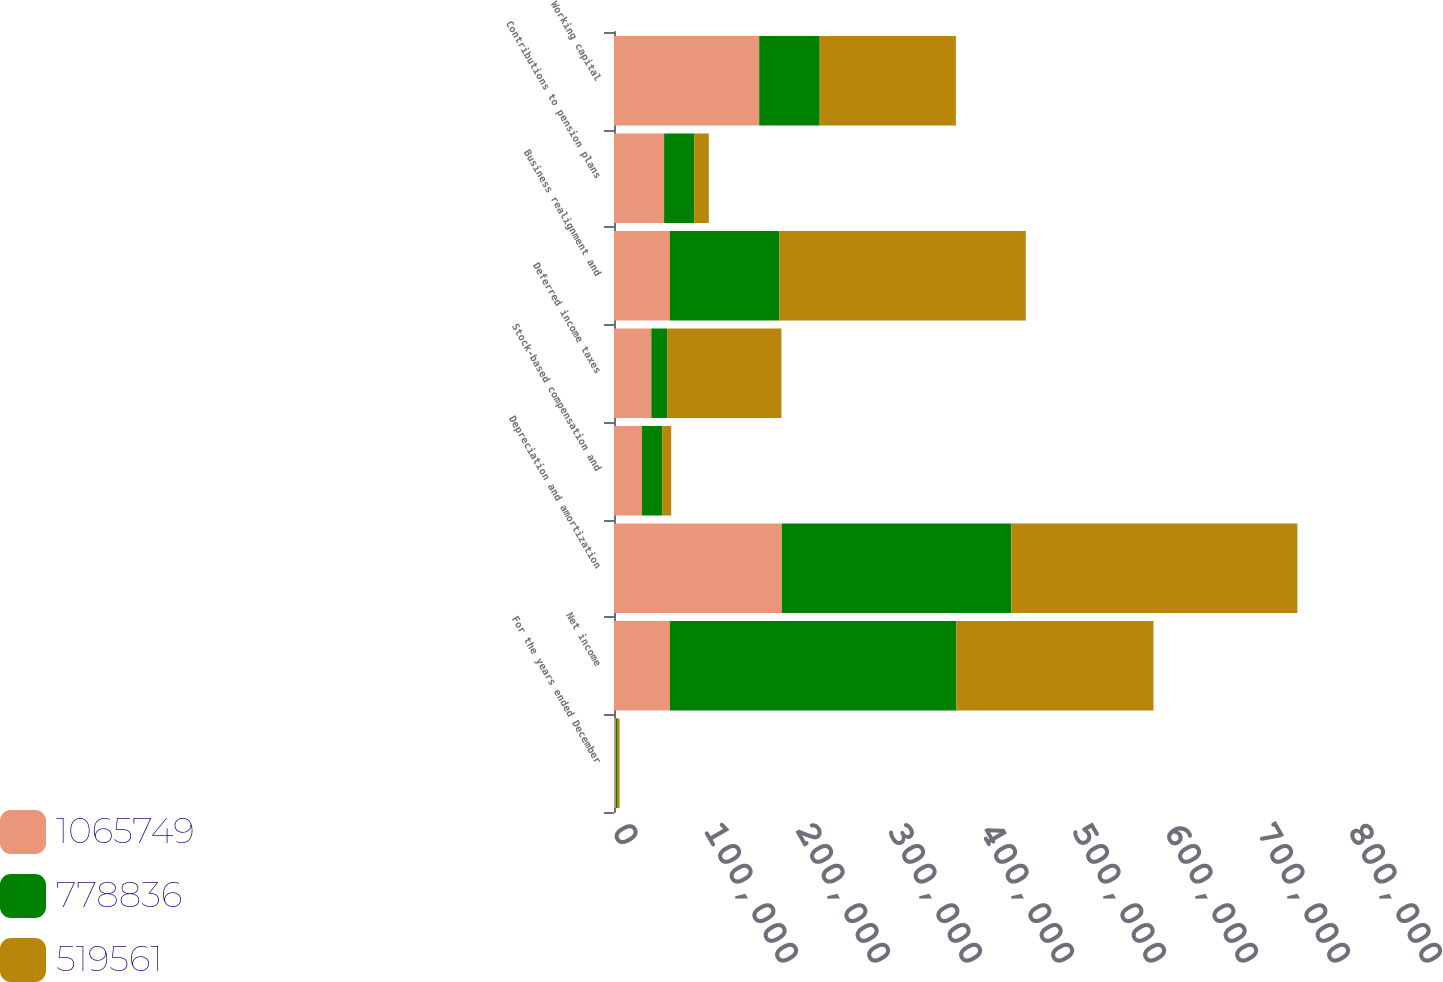Convert chart to OTSL. <chart><loc_0><loc_0><loc_500><loc_500><stacked_bar_chart><ecel><fcel>For the years ended December<fcel>Net income<fcel>Depreciation and amortization<fcel>Stock-based compensation and<fcel>Deferred income taxes<fcel>Business realignment and<fcel>Contributions to pension plans<fcel>Working capital<nl><fcel>1.06575e+06<fcel>2009<fcel>60823<fcel>182411<fcel>30472<fcel>40578<fcel>60823<fcel>54457<fcel>157812<nl><fcel>778836<fcel>2008<fcel>311405<fcel>249491<fcel>22196<fcel>17125<fcel>119117<fcel>32759<fcel>65791<nl><fcel>519561<fcel>2007<fcel>214154<fcel>310925<fcel>9526<fcel>124276<fcel>267653<fcel>15836<fcel>148019<nl></chart> 